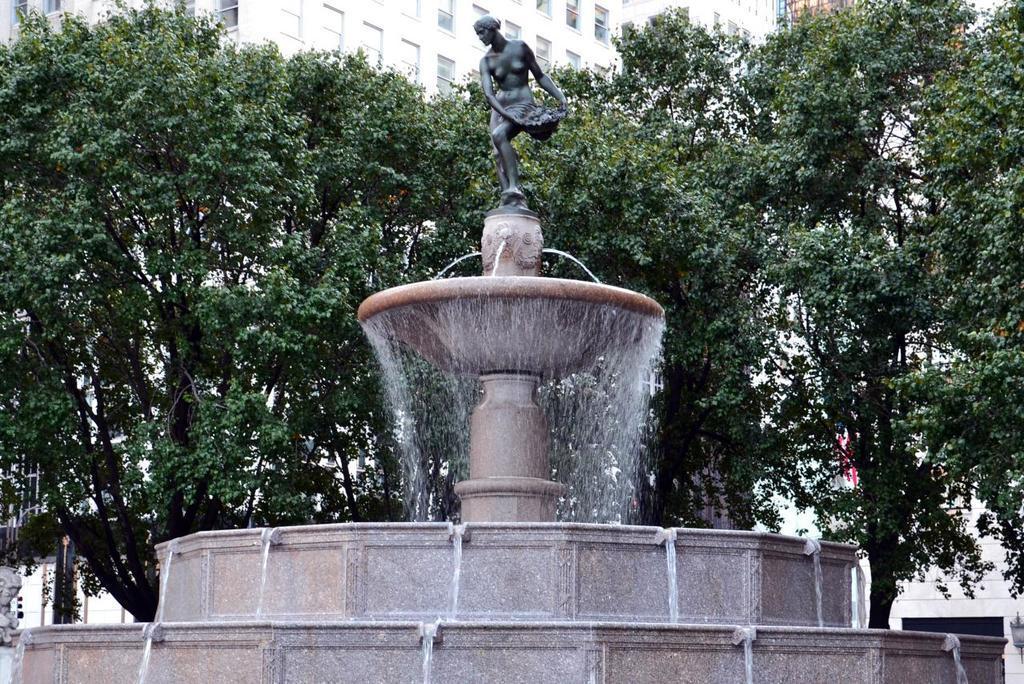Please provide a concise description of this image. In the background we can see a building with windows and trees. Here we can see a water fountain and there is a statue on a pedestal. 